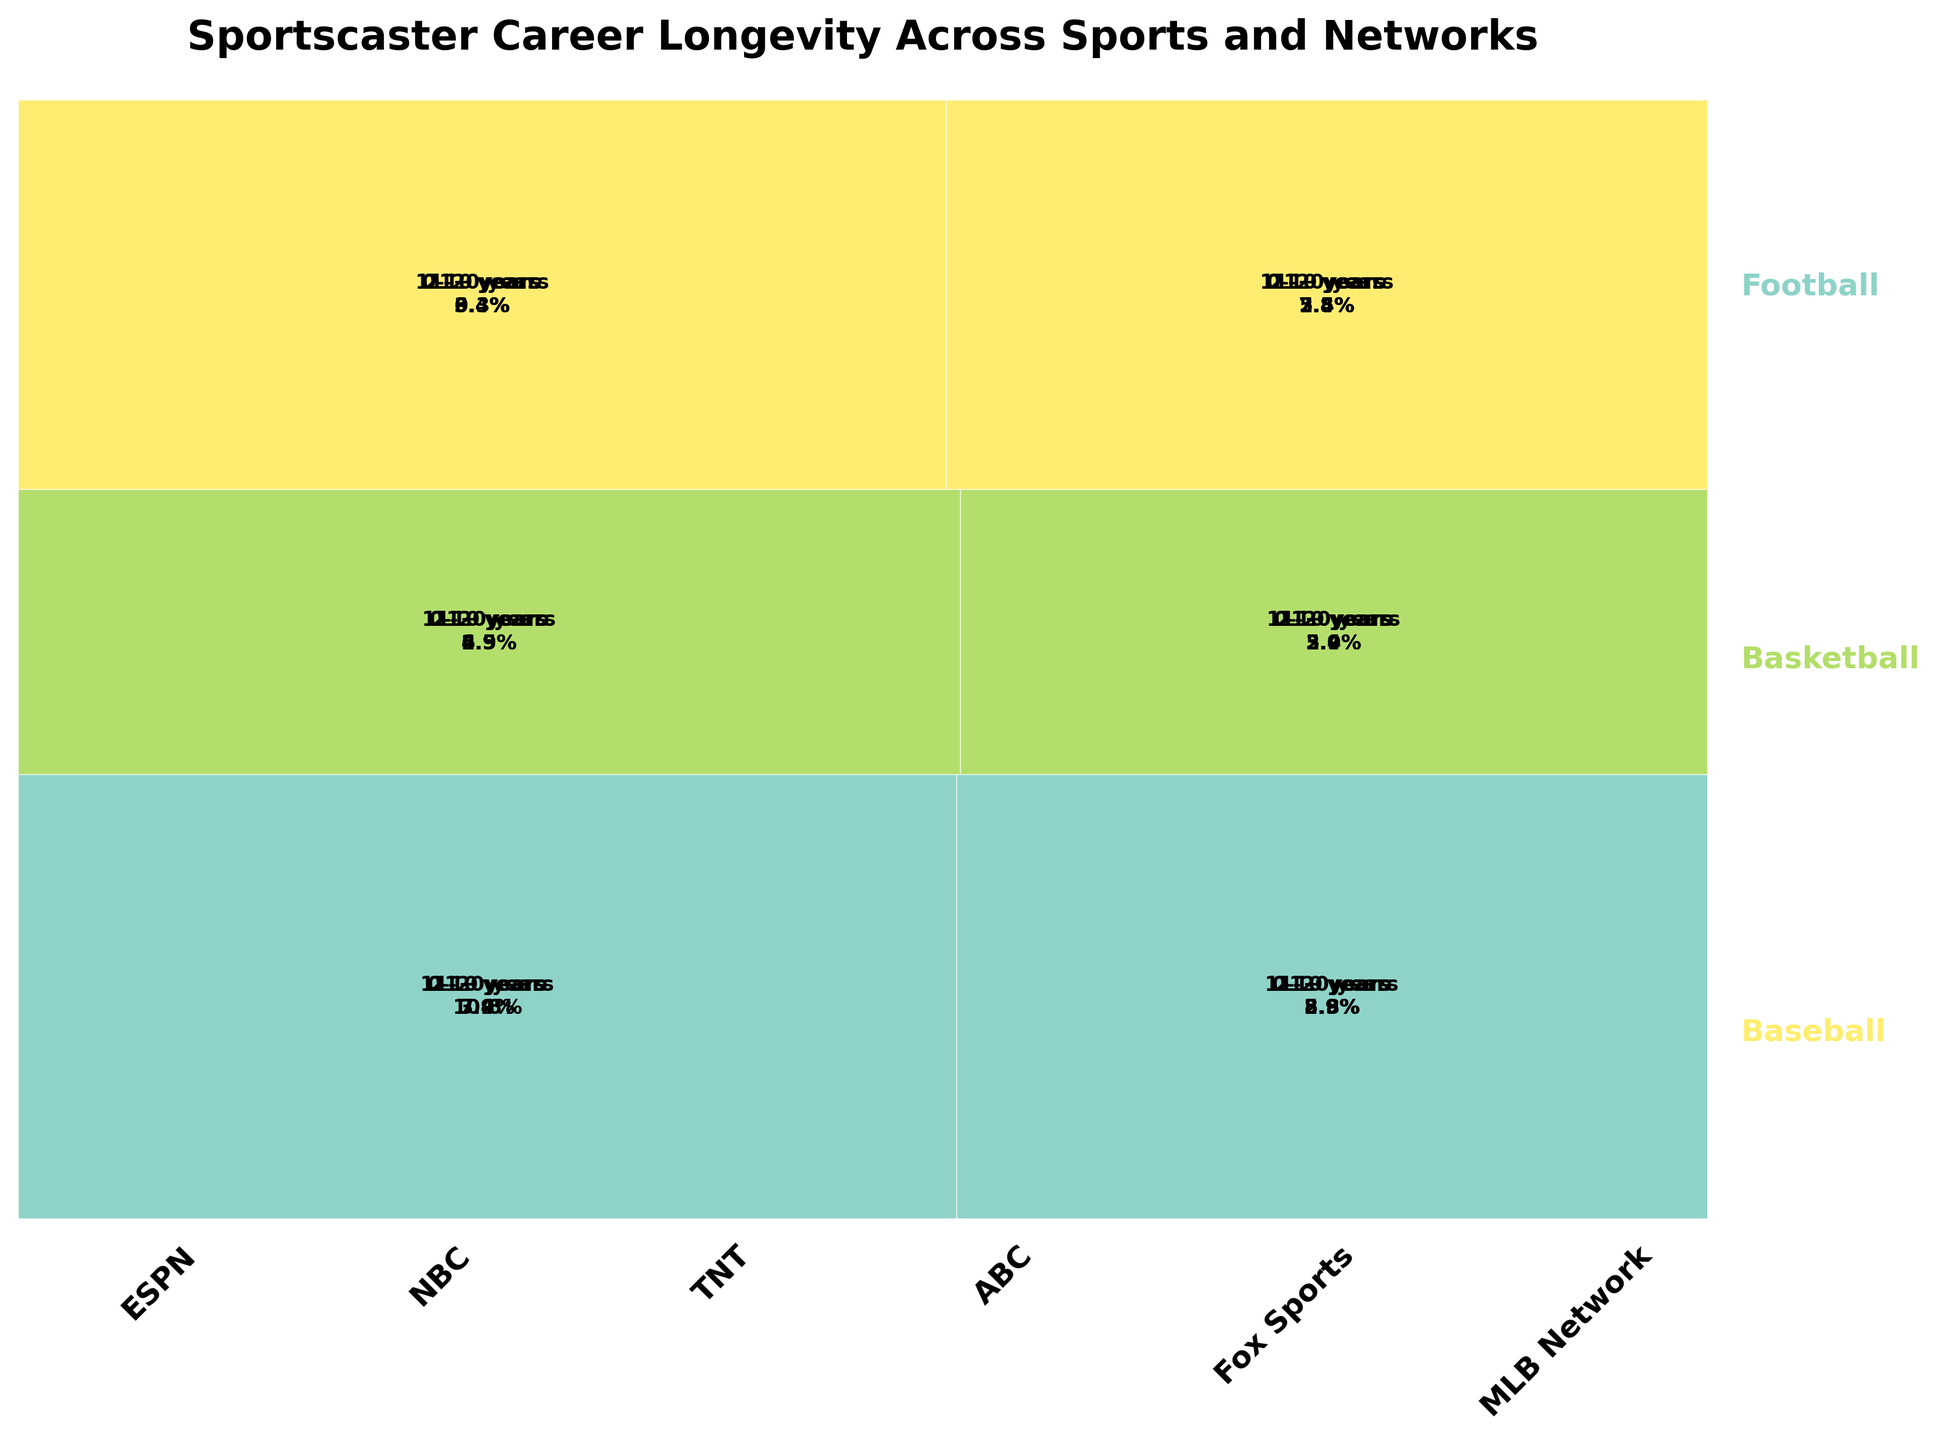what is the title of plot? The title is usually placed at the top for context. Here it reads, "Sportscaster Career Longevity Across Sports and Networks".
Answer: Sportscaster Career Longevity Across Sports and Networks Which sport has the highest proportion of sportscasters with 11-20 years career length? You need to compare the 11–20 years segment proportions across sports. By visually assessing, Football at ESPN stands out.
Answer: Football What is the career length band that appears with the highest proportion across Basketball on TNT? First, recognize the segments specific to TNT Basketball. The 11-20 years length appears to dominate visually.
Answer: 11-20 years Compare the proportion of sportscasters with 0-10 years in Football at ESPN and NBC. Which one has a higher proportion? Look at the 0-10 years segments for both networks under Football. ESPN's segment is larger comparatively.
Answer: ESPN What network has the smallest proportion of sportscasters with 21+ years in Baseball? Examine the 21+ years segments under the Baseball sections for all networks. MLB Network appears to have the smallest segment.
Answer: MLB Network Is the total number of sportscasters greater for ESPN or NBC in Football? Summing up the segments within Football for both networks, ESPN's proportions are larger collectively.
Answer: ESPN Which sport predominantly shows longer career spans (21+ years)? Visually, compare the 21+ years proportions across all segments. Football looks more predominant in the 21+ years span than others.
Answer: Football What is the proportion of sportscasters with 0-10 years career length in Basketball across all networks combined? Sum the 0-10 proportions of TNT and ABC under Basketball by assessing the segments. TNT + ABC = sum visually estimated.
Answer: 0-10 years In Baseball, which network shows a higher proportion of sportscasters with 11-20 years of experience: Fox Sports or MLB Network? Examining Baseball's 11-20 years segments for both networks visually, Fox Sports has a marginally larger segment.
Answer: Fox Sports Identify which career length category spans the smallest proportion across all sports and networks collectively. By assessing all segments, 21+ years categories seem to collectively have the smallest footprint visually.
Answer: 21+ years 